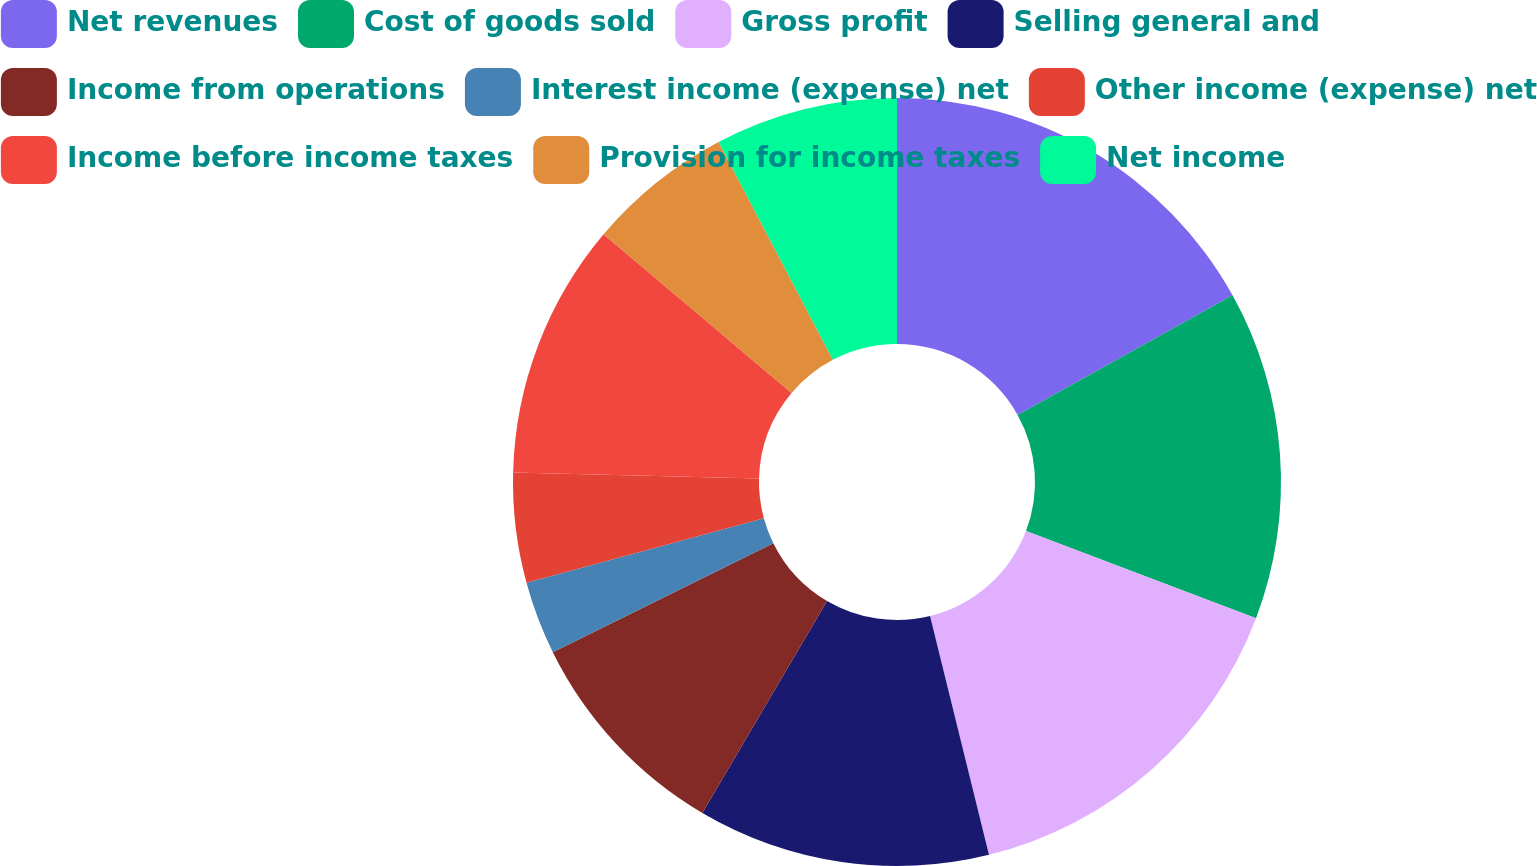<chart> <loc_0><loc_0><loc_500><loc_500><pie_chart><fcel>Net revenues<fcel>Cost of goods sold<fcel>Gross profit<fcel>Selling general and<fcel>Income from operations<fcel>Interest income (expense) net<fcel>Other income (expense) net<fcel>Income before income taxes<fcel>Provision for income taxes<fcel>Net income<nl><fcel>16.92%<fcel>13.85%<fcel>15.38%<fcel>12.31%<fcel>9.23%<fcel>3.08%<fcel>4.62%<fcel>10.77%<fcel>6.15%<fcel>7.69%<nl></chart> 